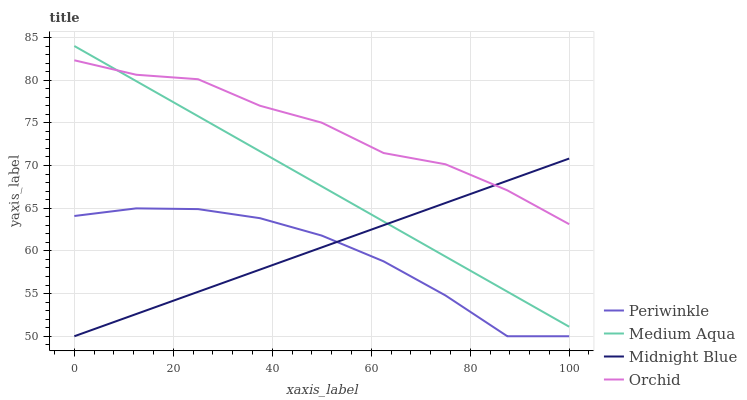Does Periwinkle have the minimum area under the curve?
Answer yes or no. Yes. Does Orchid have the maximum area under the curve?
Answer yes or no. Yes. Does Midnight Blue have the minimum area under the curve?
Answer yes or no. No. Does Midnight Blue have the maximum area under the curve?
Answer yes or no. No. Is Midnight Blue the smoothest?
Answer yes or no. Yes. Is Orchid the roughest?
Answer yes or no. Yes. Is Periwinkle the smoothest?
Answer yes or no. No. Is Periwinkle the roughest?
Answer yes or no. No. Does Orchid have the lowest value?
Answer yes or no. No. Does Medium Aqua have the highest value?
Answer yes or no. Yes. Does Midnight Blue have the highest value?
Answer yes or no. No. Is Periwinkle less than Orchid?
Answer yes or no. Yes. Is Orchid greater than Periwinkle?
Answer yes or no. Yes. Does Midnight Blue intersect Periwinkle?
Answer yes or no. Yes. Is Midnight Blue less than Periwinkle?
Answer yes or no. No. Is Midnight Blue greater than Periwinkle?
Answer yes or no. No. Does Periwinkle intersect Orchid?
Answer yes or no. No. 